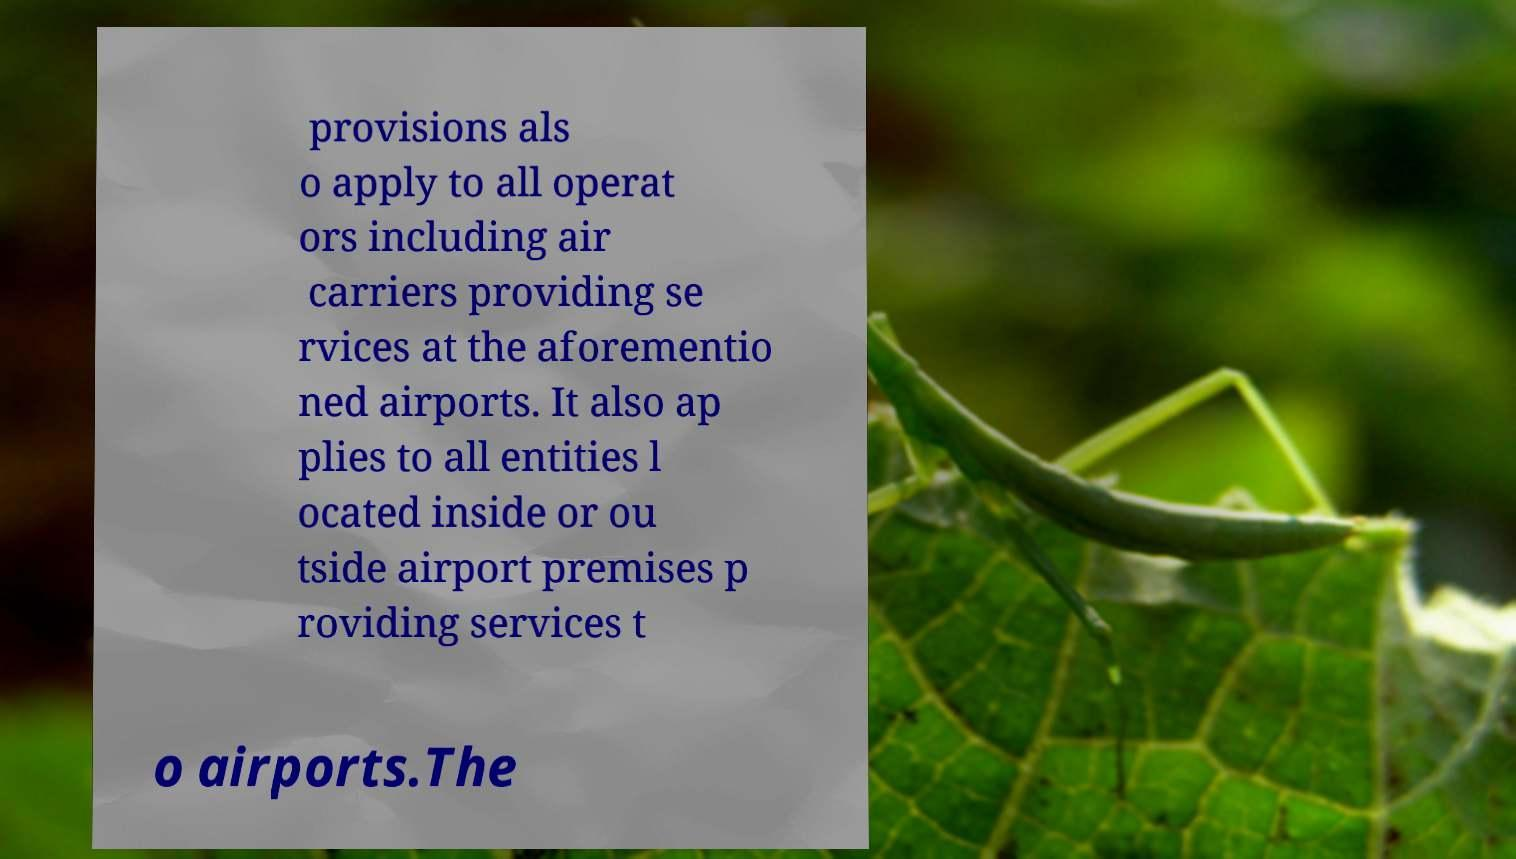Could you extract and type out the text from this image? provisions als o apply to all operat ors including air carriers providing se rvices at the aforementio ned airports. It also ap plies to all entities l ocated inside or ou tside airport premises p roviding services t o airports.The 